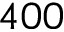<formula> <loc_0><loc_0><loc_500><loc_500>4 0 0</formula> 